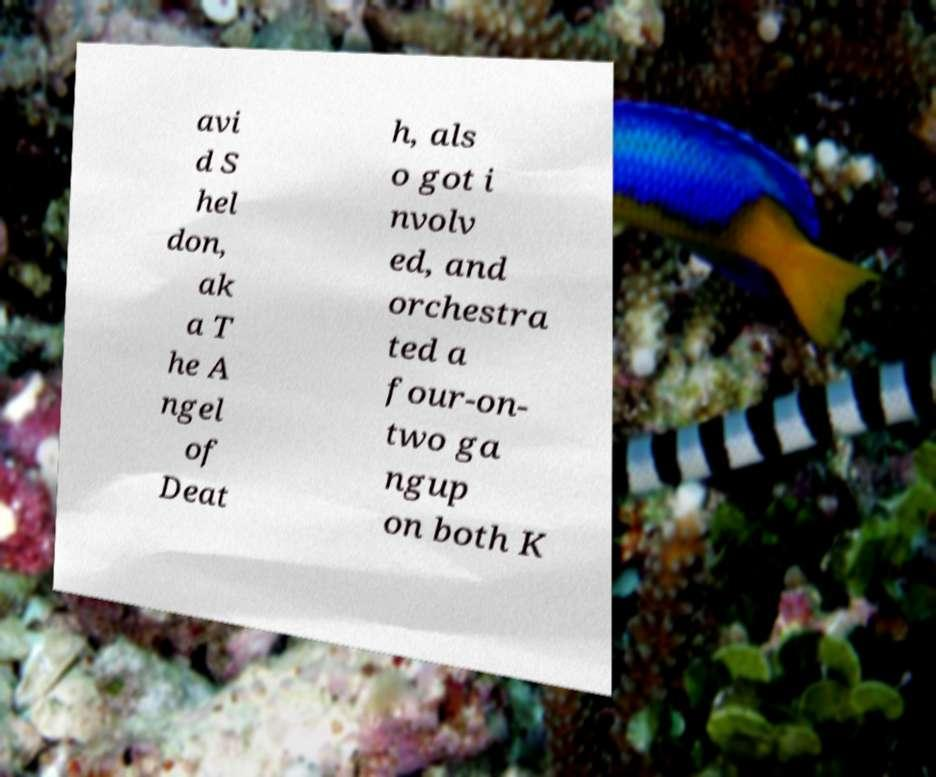Could you extract and type out the text from this image? avi d S hel don, ak a T he A ngel of Deat h, als o got i nvolv ed, and orchestra ted a four-on- two ga ngup on both K 